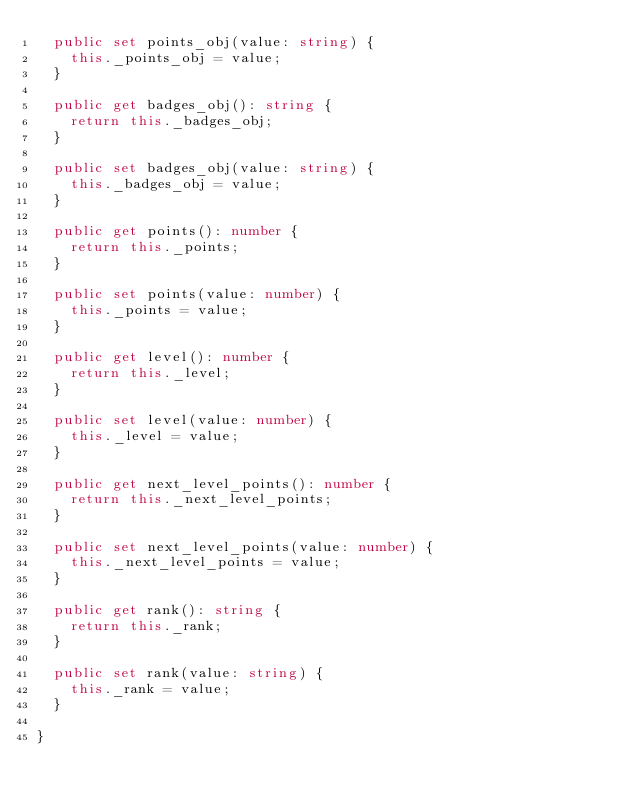Convert code to text. <code><loc_0><loc_0><loc_500><loc_500><_TypeScript_>  public set points_obj(value: string) {
    this._points_obj = value;
  }

  public get badges_obj(): string {
    return this._badges_obj;
  }

  public set badges_obj(value: string) {
    this._badges_obj = value;
  }

  public get points(): number {
    return this._points;
  }

  public set points(value: number) {
    this._points = value;
  }

  public get level(): number {
    return this._level;
  }

  public set level(value: number) {
    this._level = value;
  }

  public get next_level_points(): number {
    return this._next_level_points;
  }

  public set next_level_points(value: number) {
    this._next_level_points = value;
  }

  public get rank(): string {
    return this._rank;
  }

  public set rank(value: string) {
    this._rank = value;
  }

}
</code> 